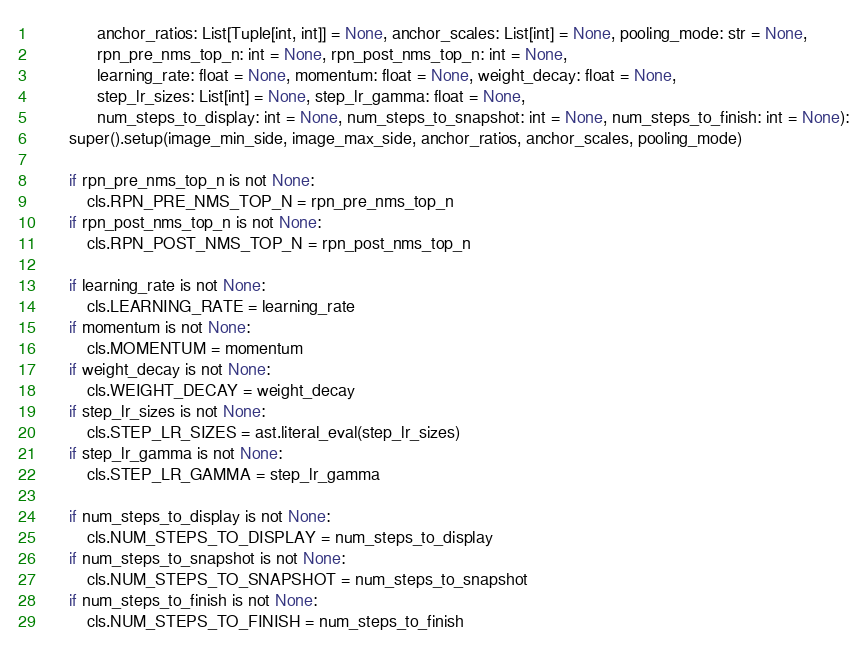Convert code to text. <code><loc_0><loc_0><loc_500><loc_500><_Python_>              anchor_ratios: List[Tuple[int, int]] = None, anchor_scales: List[int] = None, pooling_mode: str = None,
              rpn_pre_nms_top_n: int = None, rpn_post_nms_top_n: int = None,
              learning_rate: float = None, momentum: float = None, weight_decay: float = None,
              step_lr_sizes: List[int] = None, step_lr_gamma: float = None,
              num_steps_to_display: int = None, num_steps_to_snapshot: int = None, num_steps_to_finish: int = None):
        super().setup(image_min_side, image_max_side, anchor_ratios, anchor_scales, pooling_mode)

        if rpn_pre_nms_top_n is not None:
            cls.RPN_PRE_NMS_TOP_N = rpn_pre_nms_top_n
        if rpn_post_nms_top_n is not None:
            cls.RPN_POST_NMS_TOP_N = rpn_post_nms_top_n

        if learning_rate is not None:
            cls.LEARNING_RATE = learning_rate
        if momentum is not None:
            cls.MOMENTUM = momentum
        if weight_decay is not None:
            cls.WEIGHT_DECAY = weight_decay
        if step_lr_sizes is not None:
            cls.STEP_LR_SIZES = ast.literal_eval(step_lr_sizes)
        if step_lr_gamma is not None:
            cls.STEP_LR_GAMMA = step_lr_gamma

        if num_steps_to_display is not None:
            cls.NUM_STEPS_TO_DISPLAY = num_steps_to_display
        if num_steps_to_snapshot is not None:
            cls.NUM_STEPS_TO_SNAPSHOT = num_steps_to_snapshot
        if num_steps_to_finish is not None:
            cls.NUM_STEPS_TO_FINISH = num_steps_to_finish
</code> 